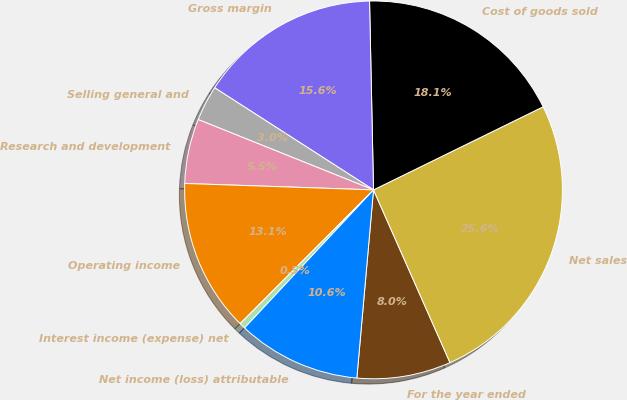<chart> <loc_0><loc_0><loc_500><loc_500><pie_chart><fcel>For the year ended<fcel>Net sales<fcel>Cost of goods sold<fcel>Gross margin<fcel>Selling general and<fcel>Research and development<fcel>Operating income<fcel>Interest income (expense) net<fcel>Net income (loss) attributable<nl><fcel>8.04%<fcel>25.61%<fcel>18.08%<fcel>15.57%<fcel>3.02%<fcel>5.53%<fcel>13.06%<fcel>0.52%<fcel>10.55%<nl></chart> 